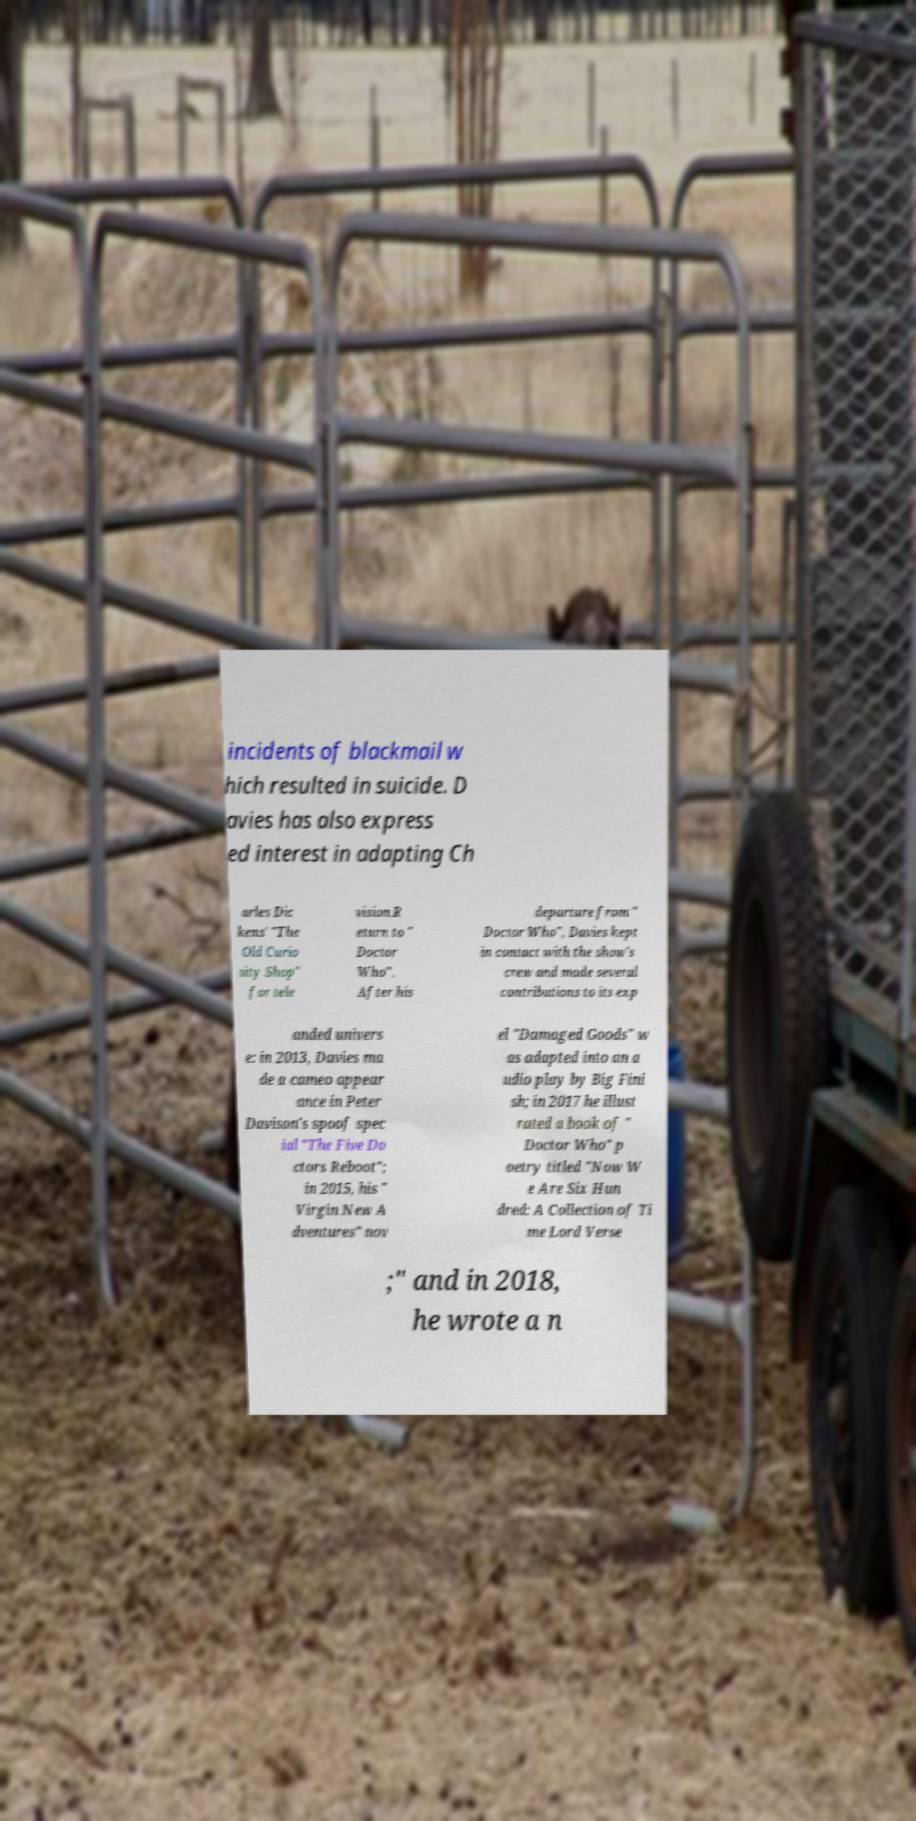For documentation purposes, I need the text within this image transcribed. Could you provide that? incidents of blackmail w hich resulted in suicide. D avies has also express ed interest in adapting Ch arles Dic kens' "The Old Curio sity Shop" for tele vision.R eturn to " Doctor Who". After his departure from " Doctor Who", Davies kept in contact with the show's crew and made several contributions to its exp anded univers e: in 2013, Davies ma de a cameo appear ance in Peter Davison's spoof spec ial "The Five Do ctors Reboot"; in 2015, his " Virgin New A dventures" nov el "Damaged Goods" w as adapted into an a udio play by Big Fini sh; in 2017 he illust rated a book of " Doctor Who" p oetry titled "Now W e Are Six Hun dred: A Collection of Ti me Lord Verse ;" and in 2018, he wrote a n 